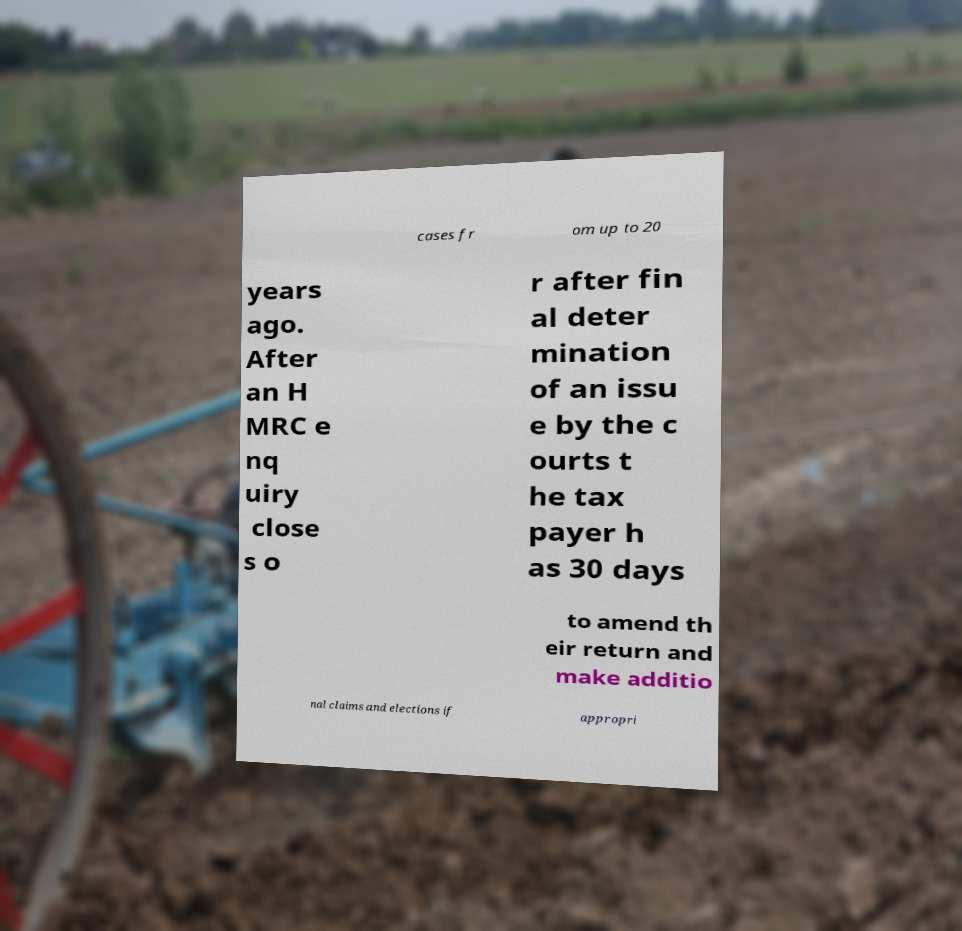Please read and relay the text visible in this image. What does it say? cases fr om up to 20 years ago. After an H MRC e nq uiry close s o r after fin al deter mination of an issu e by the c ourts t he tax payer h as 30 days to amend th eir return and make additio nal claims and elections if appropri 